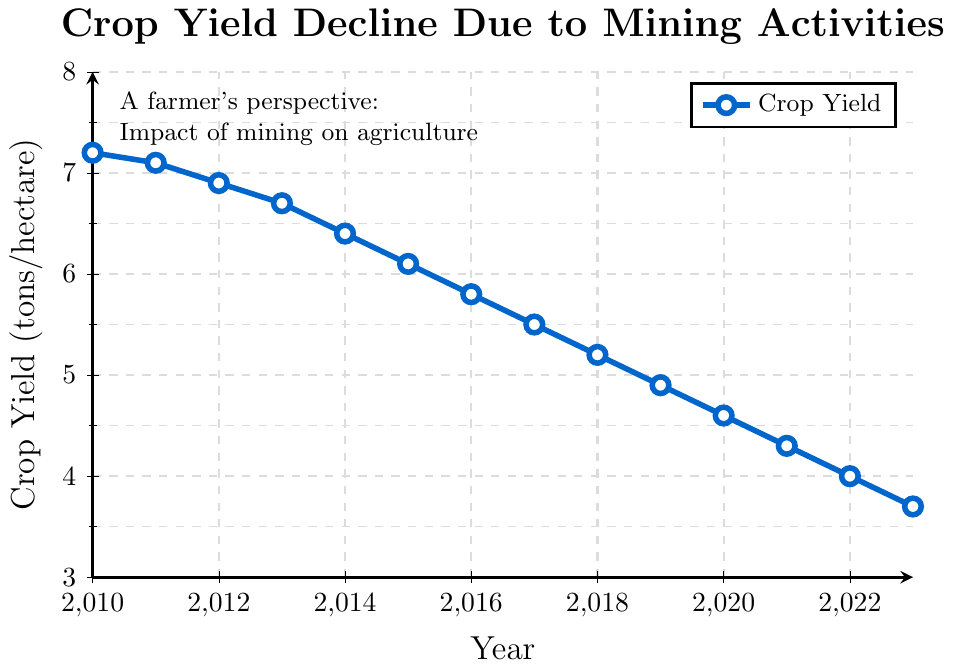What is the crop yield in 2015? To find the crop yield in 2015, locate the year 2015 on the x-axis and look at the corresponding value on the y-axis. The graph shows a yield of 6.1 tons/hectare in 2015.
Answer: 6.1 tons/hectare How much did the crop yield decrease from 2010 to 2023? First, find the crop yield in 2010 which is 7.2 tons/hectare. Then, find the crop yield in 2023 which is 3.7 tons/hectare. Subtract the 2023 value from the 2010 value: 7.2 - 3.7 = 3.5 tons/hectare.
Answer: 3.5 tons/hectare What is the average crop yield from 2018 to 2023? Identify the crop yields for the years 2018 to 2023 which are 5.2, 4.9, 4.6, 4.3, 4.0, and 3.7 tons/hectare respectively. Add these values: 5.2 + 4.9 + 4.6 + 4.3 + 4.0 + 3.7 = 26.7. Divide by the number of years (6): 26.7 / 6 = 4.45 tons/hectare on average.
Answer: 4.45 tons/hectare In which year did the crop yield first fall below 6 tons/hectare? Trace the crop yields year by year until you find the first year where the value is below 6 tons/hectare. The yield falls below 6 for the first time in 2015 with a value of 6.1, and then in 2016 it falls to 5.8 tons/hectare. Therefore, 2016 is the first year the yield is below 6 tons/hectare.
Answer: 2016 How many years did it take for the crop yield to drop from 7.2 to below 4 tons/hectare? Start by noting the initial value in 2010 (7.2 tons/hectare) and trace the values year by year until the yield drops below 4 tons/hectare. The yield drops below 4 tons/hectare in 2022, so count the number of years from 2010 to 2022: 2022 - 2010 = 12 years.
Answer: 12 years What is the median crop yield from 2010 to 2023? Arrange the crop yields in ascending order: 3.7, 4.0, 4.3, 4.6, 4.9, 5.2, 5.5, 5.8, 6.1, 6.4, 6.7, 6.9, 7.1, 7.2. The median crop yield is the middle value. For an even number of points, average the two central values. Here, 7 values are below and 7 above, so average 5.8 and 5.5: (5.8 + 5.5) / 2 = 5.65 tons/hectare.
Answer: 5.65 tons/hectare 